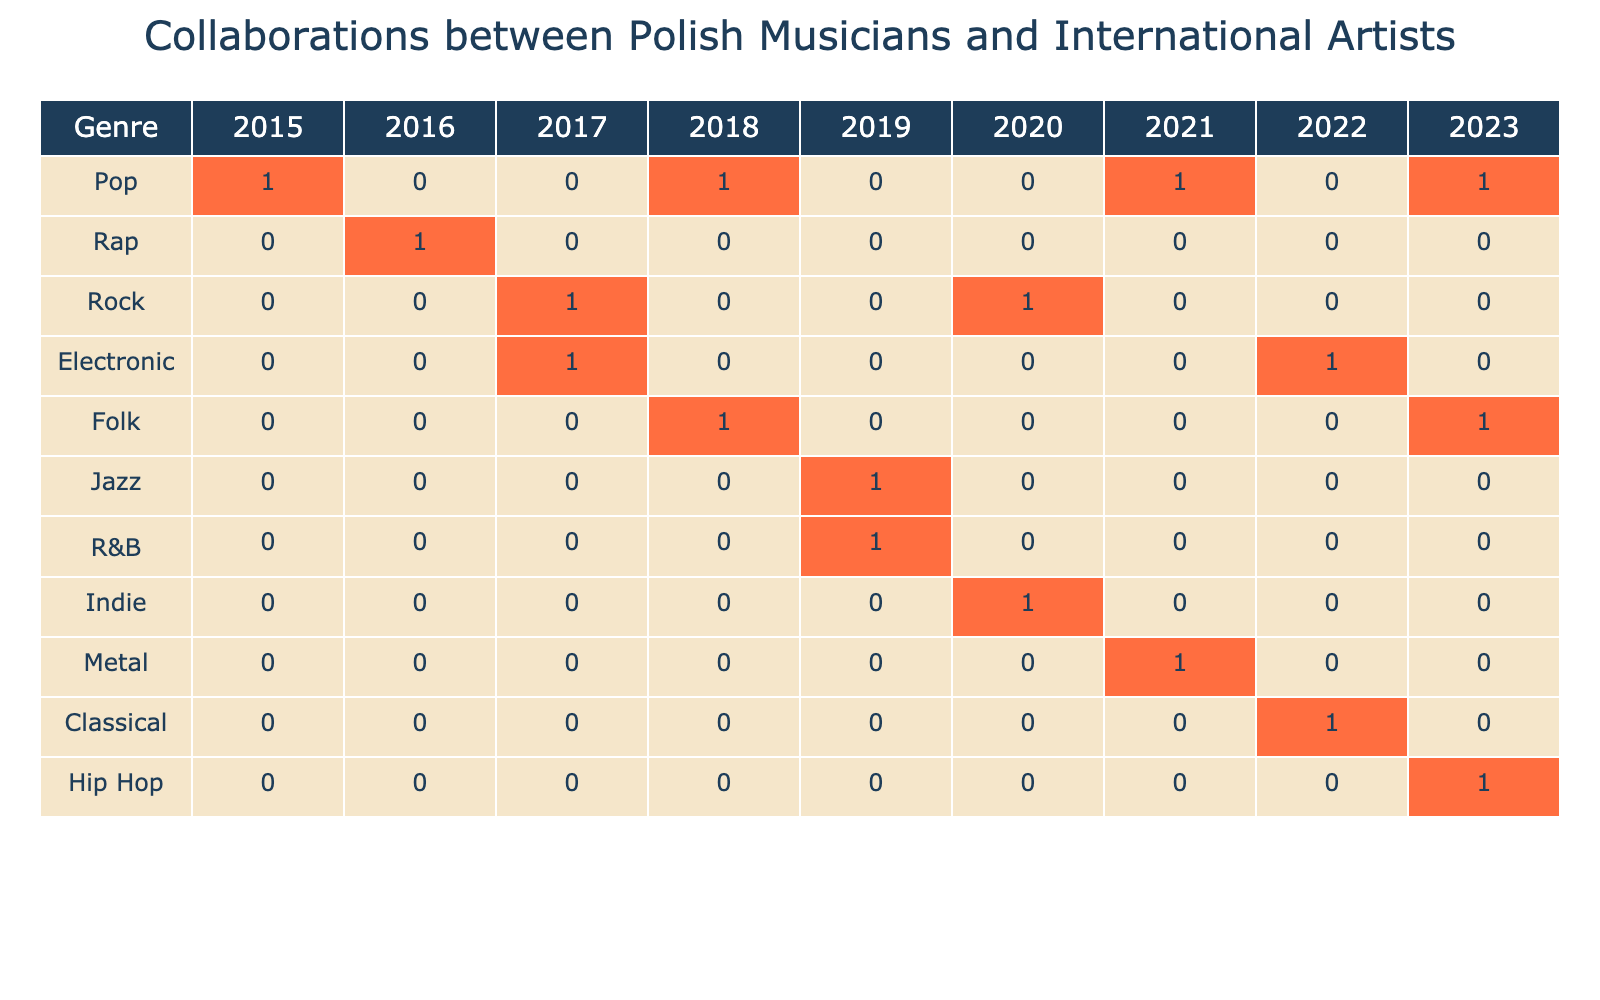What collaboration occurred in the year 2019? In the year 2019, there are two collaborations listed: Marcin Wasilewski with Pat Metheny in Jazz and Patryk Krawczyk with Beyoncé in R&B.
Answer: Marcin Wasilewski and Pat Metheny; Patryk Krawczyk and Beyoncé Which genre had the most collaborations in 2023? In 2023, there are three collaborations: Folk (Król with James Blake), Pop (Tako with Harry Styles), and Hip Hop (Syzygy with Kendrick Lamar). Therefore, no single genre has the most; they are tied with one each.
Answer: No single genre, all tied with one each How many collaborations were there in total for the genre Rock? By adding the counts from the years in the table, there are two collaborations for Rock: Coma with Slash in 2017 and Hey with The Killers in 2020.
Answer: Two collaborations Was there a collaboration between a Polish artist and a Latin American artist? None of the collaborations listed reference a Latin American artist. The mentioned international artists have origins from the U.S. or Europe.
Answer: No Which years had no collaborations in the genre Electronic? Looking through the table, the years with no Electronic collaborations are 2015, 2016, and 2019 since only 2017, 2022, and 2020 feature it.
Answer: 2015, 2016, 2019 Which genre had the least number of collaborations over the years? Counting the collaborations for each genre, Classical has one and there are no entries for several genres like Country. Therefore, Classical has the least.
Answer: Classical In which year did Pop collaborations occur most frequently? Checking the table, Pop collaborations occurred in 2015 (1), 2018 (1), 2021 (1), and 2023 (1), so no year had multiple Pop collaborations; they all have one count.
Answer: No year had multiple Pop collaborations How many collaborations involved artists from the U.S.? By examining the table, the international artists from the U.S. are Ed Sheeran, Snoop Dogg, Nick Jonas, Pat Metheny, Beyoncé, Sufjan Stevens, The Killers, Ariana Grande, and James Blake. This gives a total of eight collaborations involving U.S. artists.
Answer: Eight collaborations What is the average number of collaborations per year? There are a total of 14 collaborations from 2015 to 2023, which spans 9 years. Therefore, the average is 14 divided by 9, approximately 1.56.
Answer: Approximately 1.56 collaborations per year Identify the Polish artist who collaborated with the most diverse range of international artists. Checking the table, Julia Wieniawa, who collaborated with Nick Jonas, represents one collaboration in Pop, but across the board, Sanah also collaborated with Ariana Grande, both artists showing diversity in genre. Therefore, it ties.
Answer: Julia Wieniawa and Sanah 